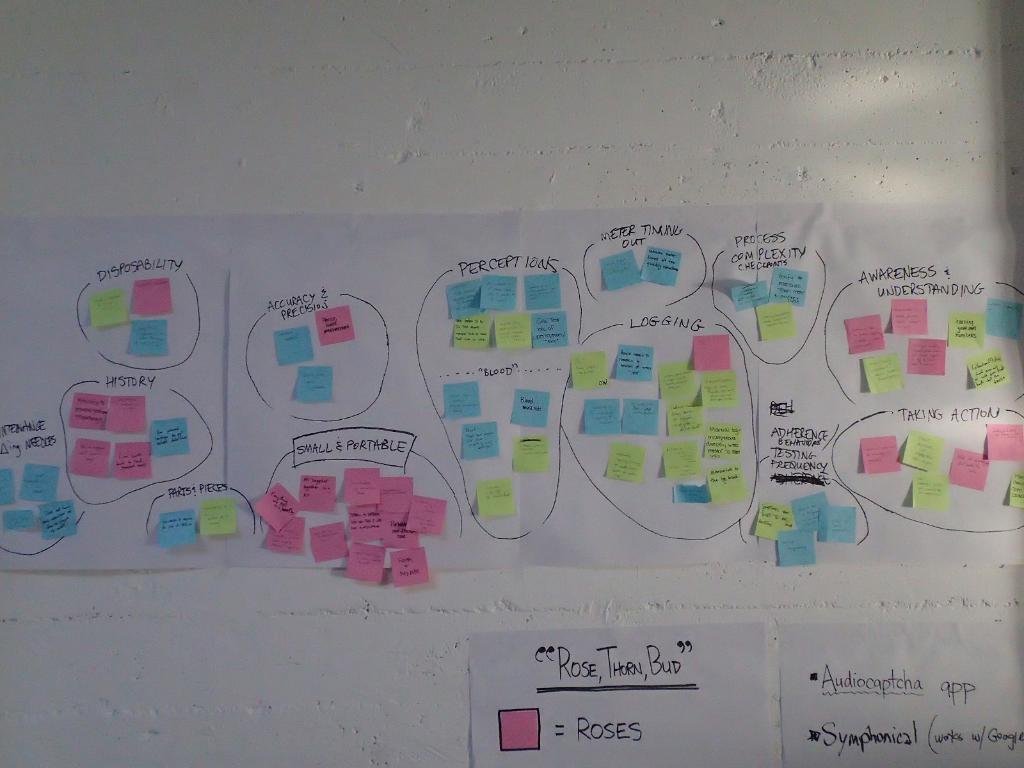In one or two sentences, can you explain what this image depicts? In this image, I can see the colorful sticky notes, which are attached to the chart papers. These chart papers are attached to the wall. 